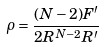<formula> <loc_0><loc_0><loc_500><loc_500>\rho = \frac { ( N - 2 ) F ^ { \prime } } { 2 R ^ { N - 2 } R ^ { \prime } }</formula> 